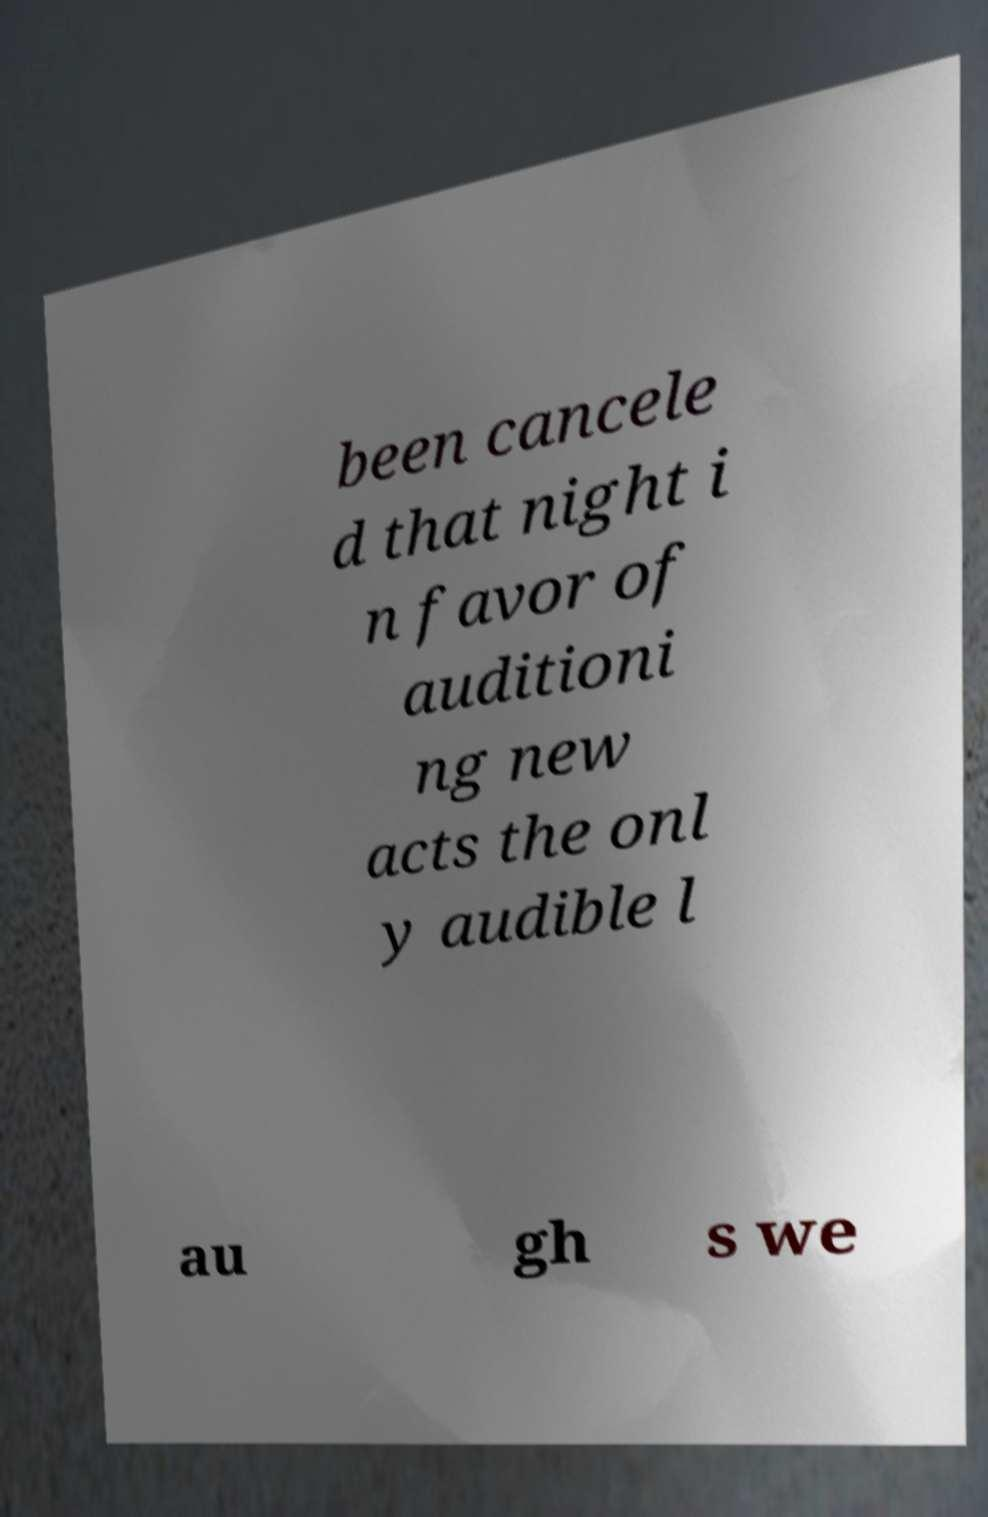For documentation purposes, I need the text within this image transcribed. Could you provide that? been cancele d that night i n favor of auditioni ng new acts the onl y audible l au gh s we 